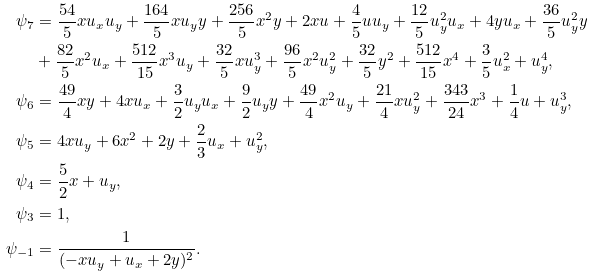<formula> <loc_0><loc_0><loc_500><loc_500>\psi _ { 7 } & = \frac { 5 4 } { 5 } x u _ { x } u _ { y } + \frac { 1 6 4 } { 5 } x u _ { y } y + \frac { 2 5 6 } { 5 } x ^ { 2 } y + 2 x u + \frac { 4 } { 5 } u u _ { y } + \frac { 1 2 } { 5 } u _ { y } ^ { 2 } u _ { x } + 4 y u _ { x } + \frac { 3 6 } { 5 } u _ { y } ^ { 2 } y \\ & + \frac { 8 2 } { 5 } x ^ { 2 } u _ { x } + \frac { 5 1 2 } { 1 5 } x ^ { 3 } u _ { y } + \frac { 3 2 } { 5 } x u _ { y } ^ { 3 } + \frac { 9 6 } { 5 } x ^ { 2 } u _ { y } ^ { 2 } + \frac { 3 2 } { 5 } y ^ { 2 } + \frac { 5 1 2 } { 1 5 } x ^ { 4 } + \frac { 3 } { 5 } u _ { x } ^ { 2 } + u _ { y } ^ { 4 } , \\ \psi _ { 6 } & = \frac { 4 9 } { 4 } x y + 4 x u _ { x } + \frac { 3 } { 2 } u _ { y } u _ { x } + \frac { 9 } { 2 } u _ { y } y + \frac { 4 9 } { 4 } x ^ { 2 } u _ { y } + \frac { 2 1 } { 4 } x u _ { y } ^ { 2 } + \frac { 3 4 3 } { 2 4 } x ^ { 3 } + \frac { 1 } { 4 } u + u _ { y } ^ { 3 } , \\ \psi _ { 5 } & = 4 x u _ { y } + 6 x ^ { 2 } + 2 y + \frac { 2 } { 3 } u _ { x } + u _ { y } ^ { 2 } , \\ \psi _ { 4 } & = \frac { 5 } { 2 } x + u _ { y } , \\ \psi _ { 3 } & = 1 , \\ \psi _ { - 1 } & = \frac { 1 } { ( - x u _ { y } + u _ { x } + 2 y ) ^ { 2 } } .</formula> 